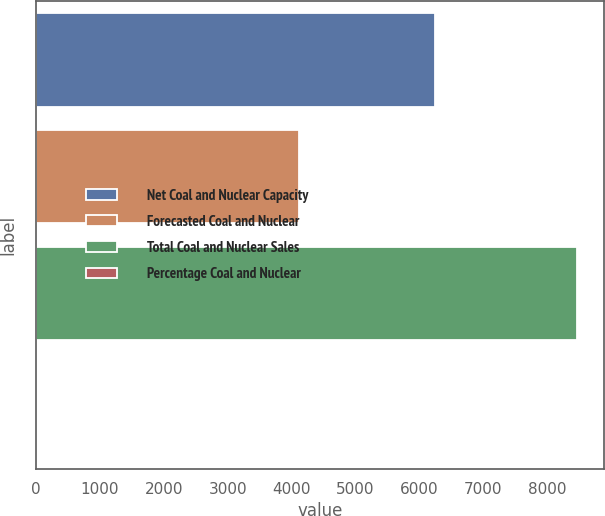Convert chart to OTSL. <chart><loc_0><loc_0><loc_500><loc_500><bar_chart><fcel>Net Coal and Nuclear Capacity<fcel>Forecasted Coal and Nuclear<fcel>Total Coal and Nuclear Sales<fcel>Percentage Coal and Nuclear<nl><fcel>6250<fcel>4119<fcel>8471<fcel>23<nl></chart> 